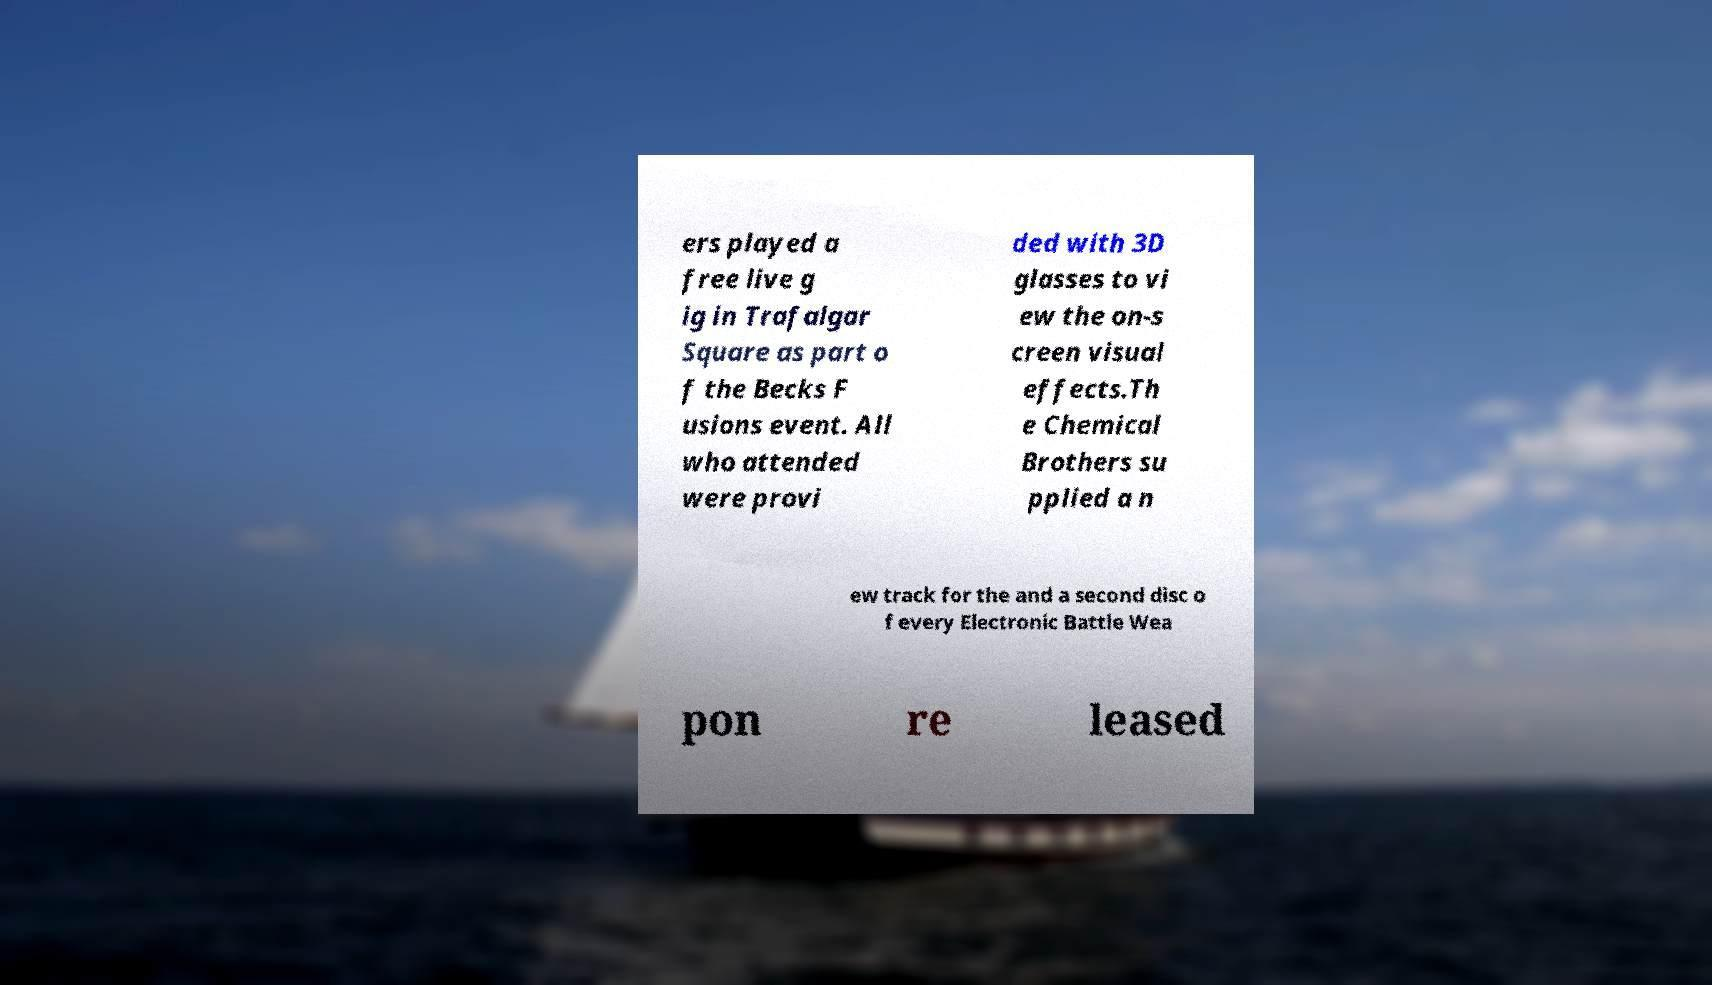There's text embedded in this image that I need extracted. Can you transcribe it verbatim? ers played a free live g ig in Trafalgar Square as part o f the Becks F usions event. All who attended were provi ded with 3D glasses to vi ew the on-s creen visual effects.Th e Chemical Brothers su pplied a n ew track for the and a second disc o f every Electronic Battle Wea pon re leased 